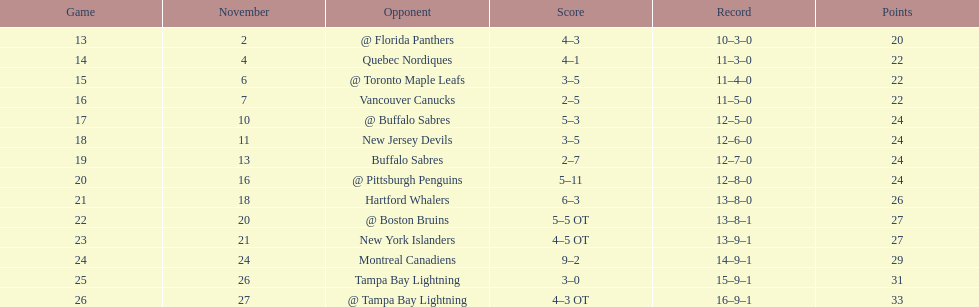What was the total penalty minutes that dave brown had on the 1993-1994 flyers? 137. 